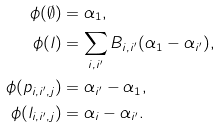Convert formula to latex. <formula><loc_0><loc_0><loc_500><loc_500>\phi ( \emptyset ) & = \alpha _ { 1 } , \\ \phi ( l ) & = \sum _ { i , i ^ { \prime } } B _ { i , i ^ { \prime } } ( \alpha _ { 1 } - \alpha _ { i ^ { \prime } } ) , \\ \phi ( p _ { i , i ^ { \prime } , j } ) & = \alpha _ { i ^ { \prime } } - \alpha _ { 1 } , \\ \phi ( l _ { i , i ^ { \prime } , j } ) & = \alpha _ { i } - \alpha _ { i ^ { \prime } } .</formula> 